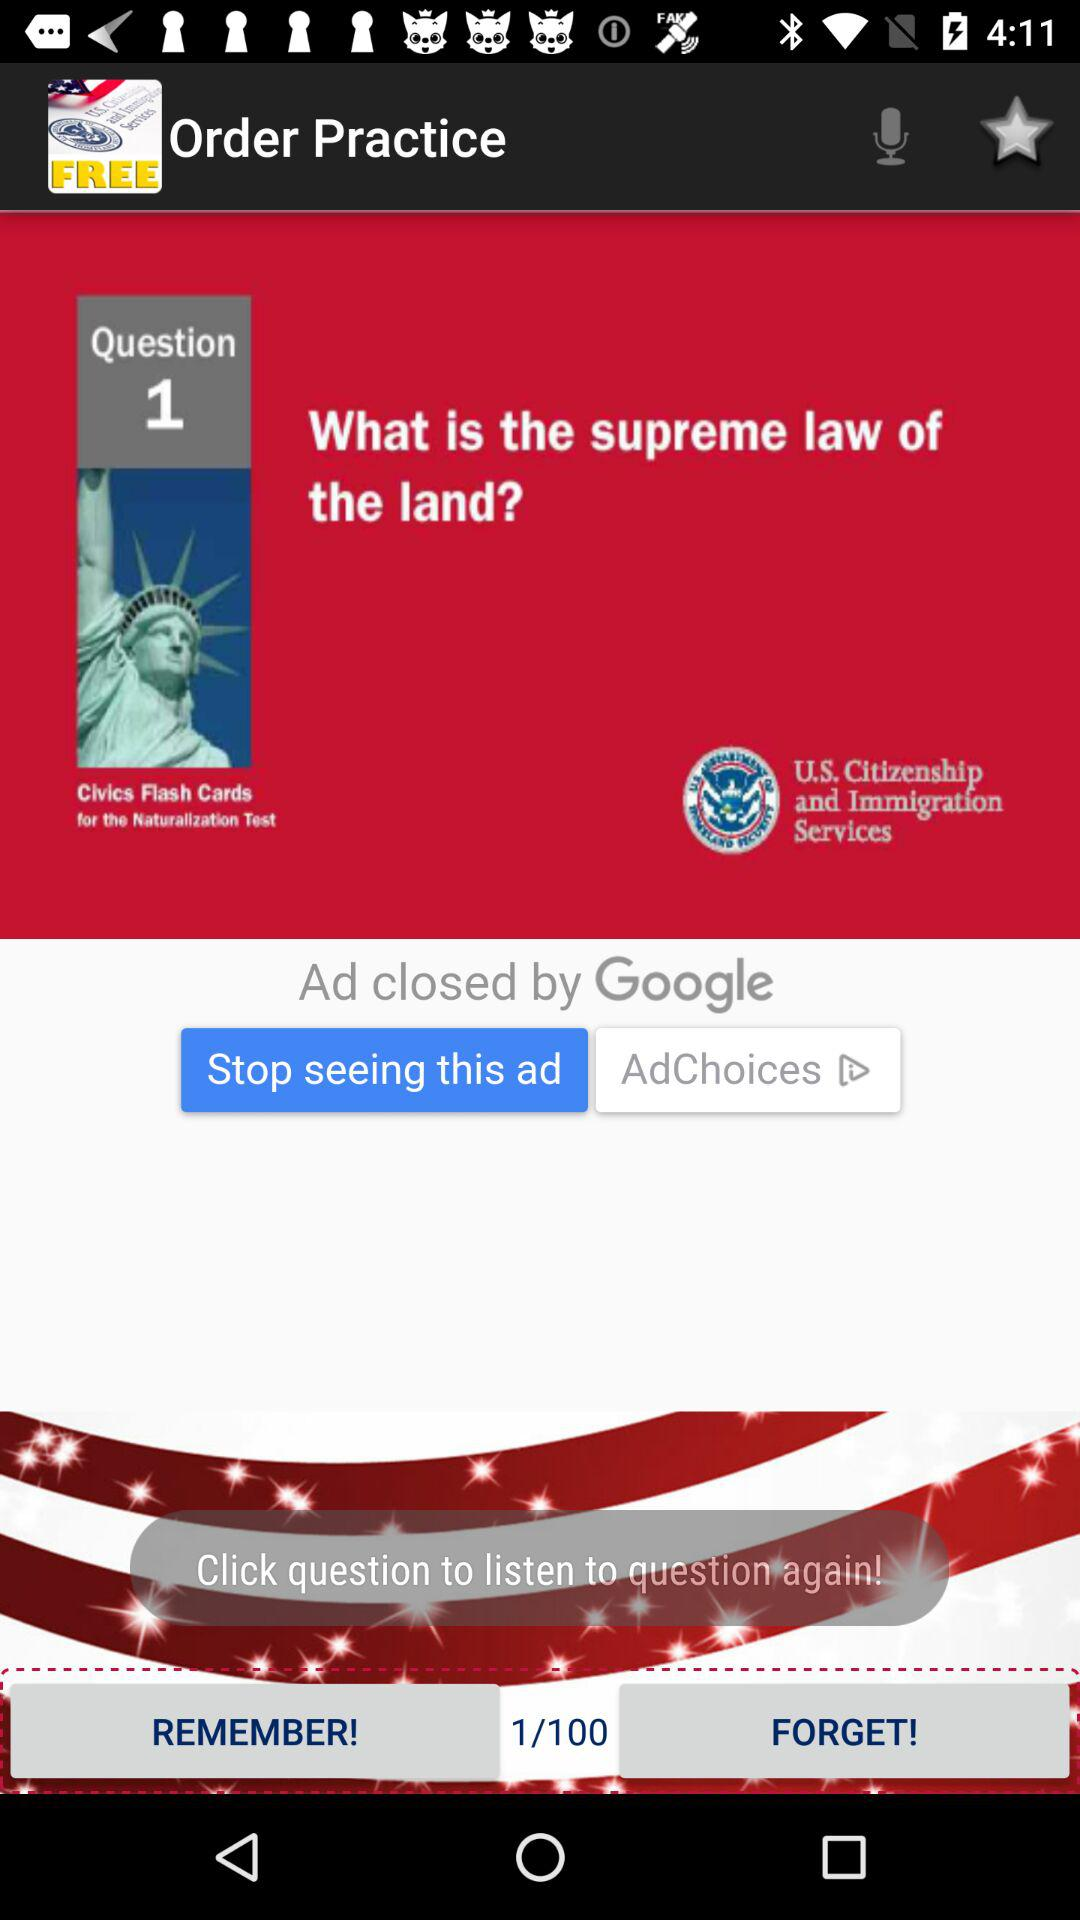What is question #2?
When the provided information is insufficient, respond with <no answer>. <no answer> 